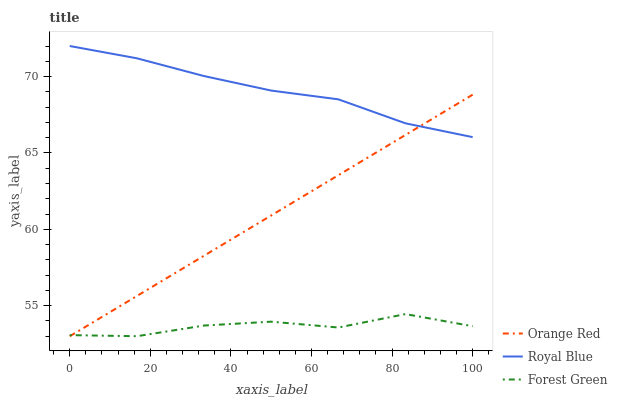Does Orange Red have the minimum area under the curve?
Answer yes or no. No. Does Orange Red have the maximum area under the curve?
Answer yes or no. No. Is Forest Green the smoothest?
Answer yes or no. No. Is Orange Red the roughest?
Answer yes or no. No. Does Forest Green have the lowest value?
Answer yes or no. No. Does Orange Red have the highest value?
Answer yes or no. No. Is Forest Green less than Royal Blue?
Answer yes or no. Yes. Is Royal Blue greater than Forest Green?
Answer yes or no. Yes. Does Forest Green intersect Royal Blue?
Answer yes or no. No. 